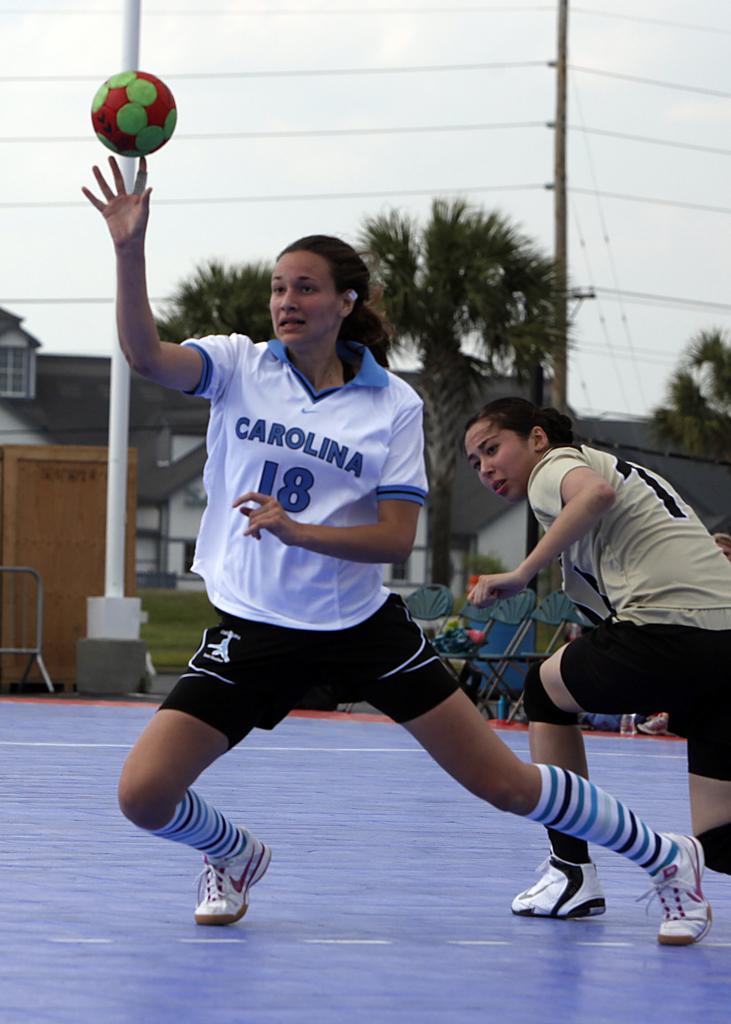Describe this image in one or two sentences. In this image in the center there are persons playing a game. In the front there is a ball. In the background there are trees, buildings, poles, wire and there is grass on the ground and the sky is cloudy. 